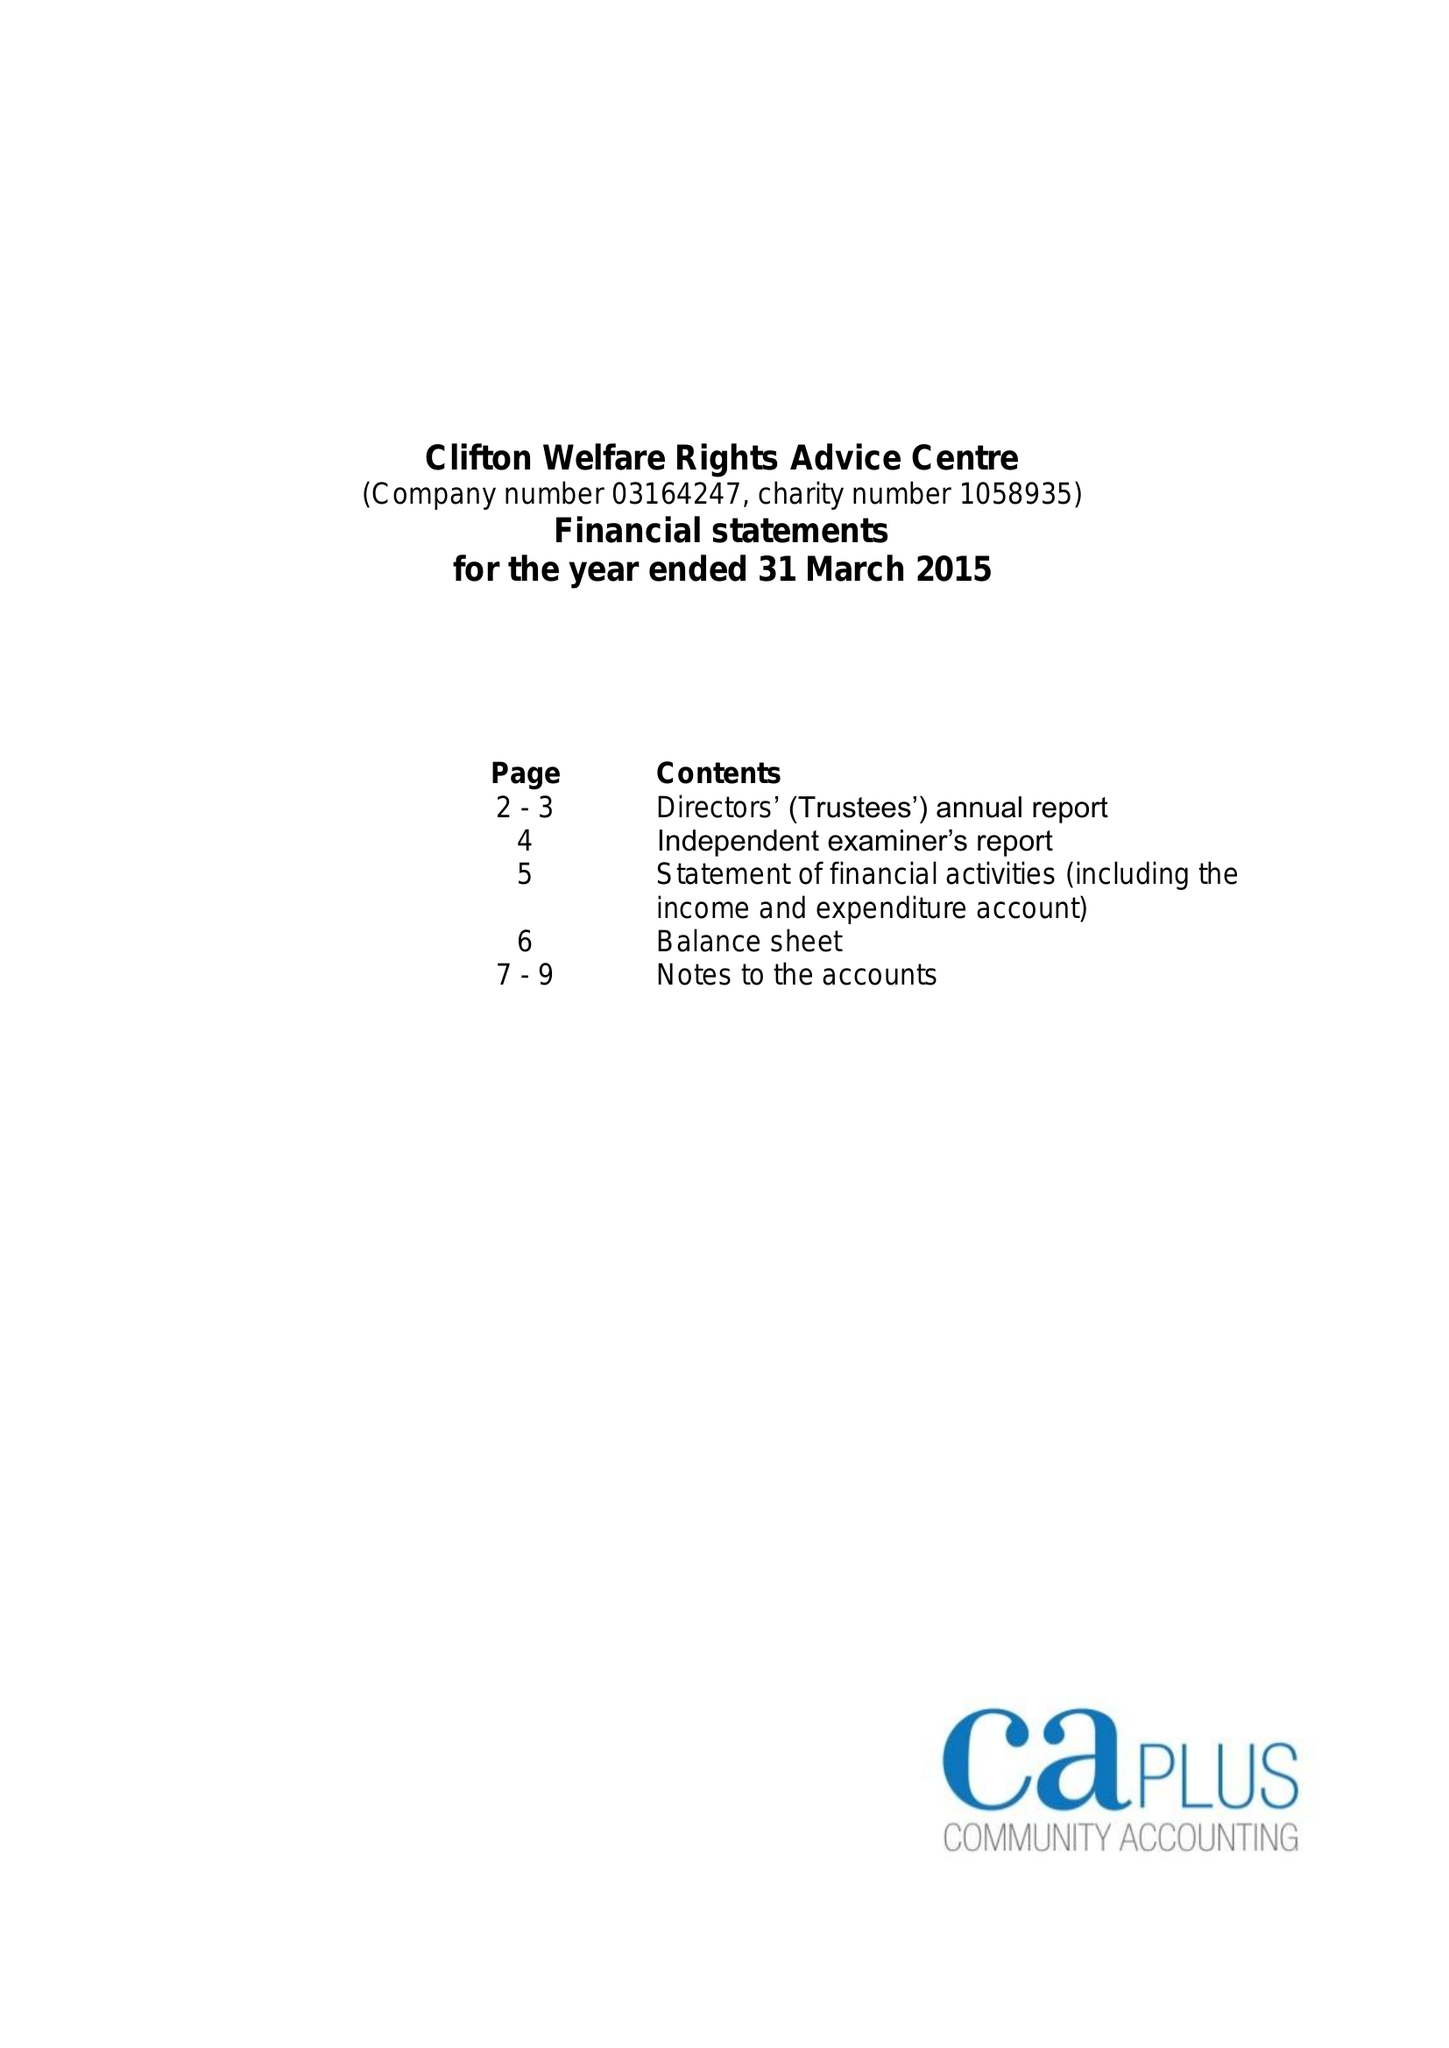What is the value for the charity_number?
Answer the question using a single word or phrase. 1058935 